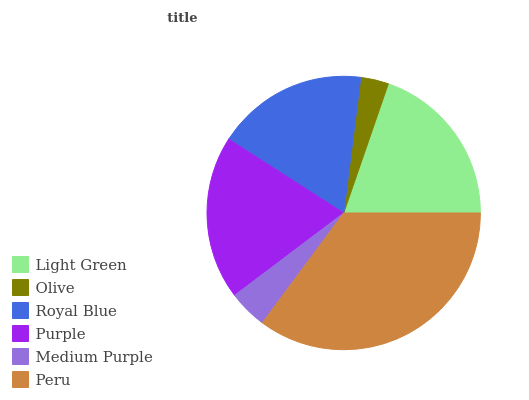Is Olive the minimum?
Answer yes or no. Yes. Is Peru the maximum?
Answer yes or no. Yes. Is Royal Blue the minimum?
Answer yes or no. No. Is Royal Blue the maximum?
Answer yes or no. No. Is Royal Blue greater than Olive?
Answer yes or no. Yes. Is Olive less than Royal Blue?
Answer yes or no. Yes. Is Olive greater than Royal Blue?
Answer yes or no. No. Is Royal Blue less than Olive?
Answer yes or no. No. Is Purple the high median?
Answer yes or no. Yes. Is Royal Blue the low median?
Answer yes or no. Yes. Is Olive the high median?
Answer yes or no. No. Is Olive the low median?
Answer yes or no. No. 